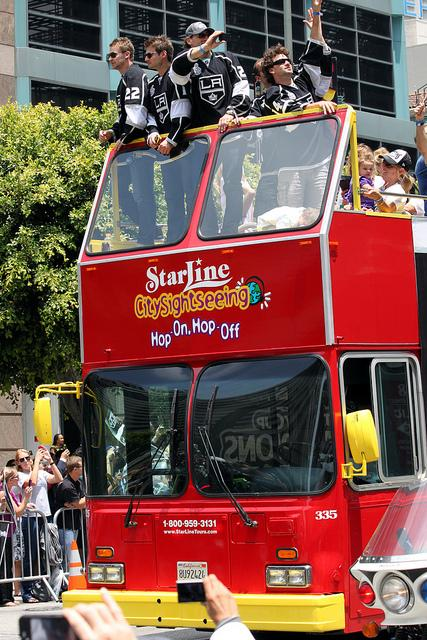The person on the motorcycle escorting the double decker bus is what type of public servant?

Choices:
A) fireman
B) soldier
C) policeman
D) inspector policeman 